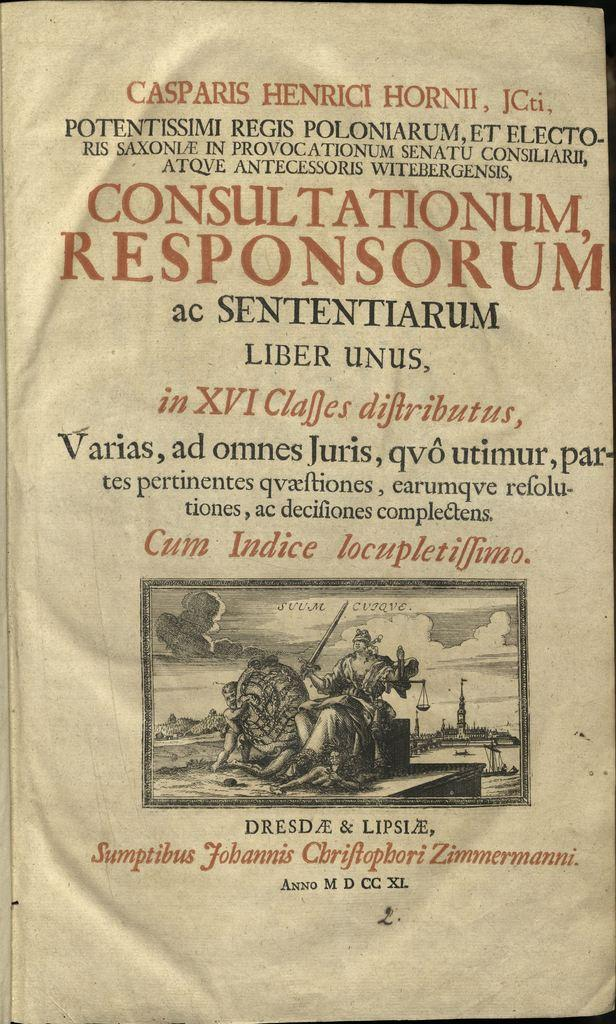Provide a one-sentence caption for the provided image. Finishing this page from an old book is the line "Anno M D CC XL". 